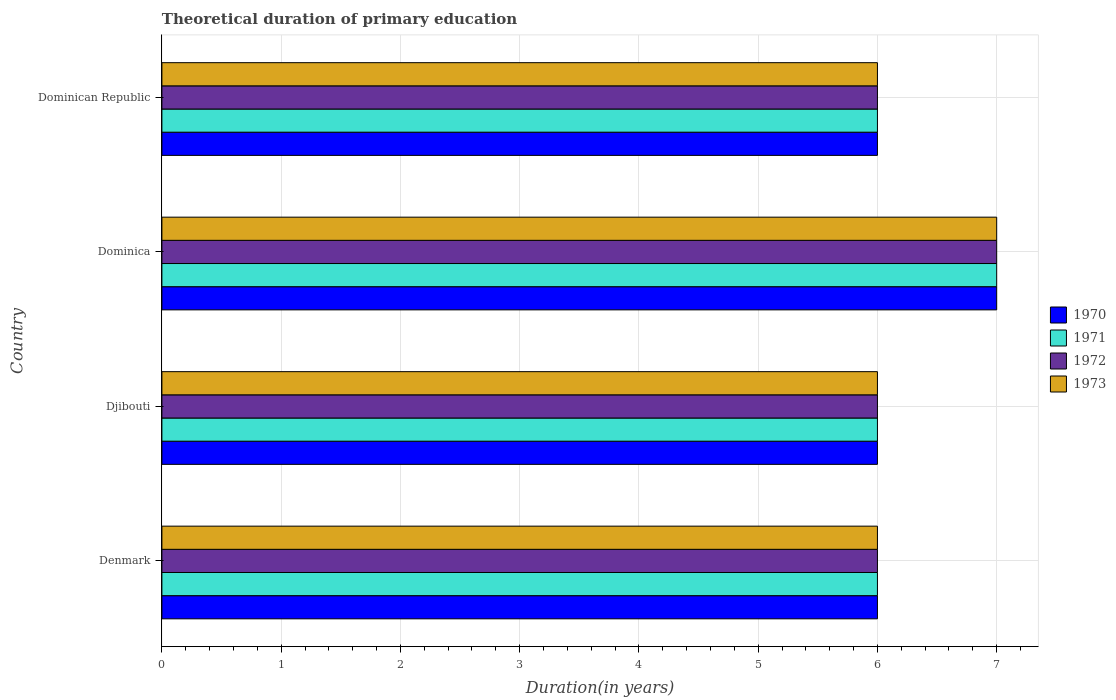How many different coloured bars are there?
Your answer should be very brief. 4. How many groups of bars are there?
Provide a succinct answer. 4. Are the number of bars on each tick of the Y-axis equal?
Provide a short and direct response. Yes. How many bars are there on the 3rd tick from the top?
Your answer should be very brief. 4. What is the label of the 2nd group of bars from the top?
Offer a very short reply. Dominica. Across all countries, what is the maximum total theoretical duration of primary education in 1972?
Offer a very short reply. 7. Across all countries, what is the minimum total theoretical duration of primary education in 1971?
Ensure brevity in your answer.  6. In which country was the total theoretical duration of primary education in 1971 maximum?
Offer a terse response. Dominica. What is the difference between the total theoretical duration of primary education in 1971 in Djibouti and that in Dominica?
Offer a terse response. -1. What is the difference between the total theoretical duration of primary education in 1970 in Denmark and the total theoretical duration of primary education in 1972 in Djibouti?
Provide a succinct answer. 0. What is the average total theoretical duration of primary education in 1972 per country?
Give a very brief answer. 6.25. What is the ratio of the total theoretical duration of primary education in 1971 in Dominica to that in Dominican Republic?
Ensure brevity in your answer.  1.17. Is the difference between the total theoretical duration of primary education in 1971 in Denmark and Dominica greater than the difference between the total theoretical duration of primary education in 1972 in Denmark and Dominica?
Offer a very short reply. No. In how many countries, is the total theoretical duration of primary education in 1971 greater than the average total theoretical duration of primary education in 1971 taken over all countries?
Offer a terse response. 1. What does the 4th bar from the top in Denmark represents?
Make the answer very short. 1970. Is it the case that in every country, the sum of the total theoretical duration of primary education in 1971 and total theoretical duration of primary education in 1972 is greater than the total theoretical duration of primary education in 1970?
Your answer should be very brief. Yes. Are all the bars in the graph horizontal?
Make the answer very short. Yes. How many countries are there in the graph?
Offer a terse response. 4. What is the difference between two consecutive major ticks on the X-axis?
Provide a short and direct response. 1. Does the graph contain any zero values?
Provide a short and direct response. No. Does the graph contain grids?
Your response must be concise. Yes. Where does the legend appear in the graph?
Provide a short and direct response. Center right. How many legend labels are there?
Offer a terse response. 4. How are the legend labels stacked?
Offer a very short reply. Vertical. What is the title of the graph?
Your answer should be compact. Theoretical duration of primary education. Does "2001" appear as one of the legend labels in the graph?
Provide a succinct answer. No. What is the label or title of the X-axis?
Your answer should be very brief. Duration(in years). What is the Duration(in years) of 1970 in Denmark?
Provide a succinct answer. 6. What is the Duration(in years) of 1971 in Denmark?
Provide a short and direct response. 6. What is the Duration(in years) of 1972 in Denmark?
Offer a terse response. 6. What is the Duration(in years) in 1973 in Denmark?
Your answer should be very brief. 6. What is the Duration(in years) of 1970 in Djibouti?
Offer a very short reply. 6. What is the Duration(in years) of 1972 in Djibouti?
Provide a short and direct response. 6. What is the Duration(in years) of 1972 in Dominica?
Ensure brevity in your answer.  7. What is the Duration(in years) in 1972 in Dominican Republic?
Offer a terse response. 6. Across all countries, what is the maximum Duration(in years) of 1972?
Make the answer very short. 7. Across all countries, what is the maximum Duration(in years) of 1973?
Keep it short and to the point. 7. Across all countries, what is the minimum Duration(in years) of 1972?
Your answer should be compact. 6. What is the total Duration(in years) in 1973 in the graph?
Your response must be concise. 25. What is the difference between the Duration(in years) in 1972 in Denmark and that in Djibouti?
Your answer should be very brief. 0. What is the difference between the Duration(in years) in 1971 in Denmark and that in Dominica?
Provide a short and direct response. -1. What is the difference between the Duration(in years) of 1970 in Denmark and that in Dominican Republic?
Ensure brevity in your answer.  0. What is the difference between the Duration(in years) of 1971 in Denmark and that in Dominican Republic?
Ensure brevity in your answer.  0. What is the difference between the Duration(in years) in 1972 in Denmark and that in Dominican Republic?
Keep it short and to the point. 0. What is the difference between the Duration(in years) in 1971 in Djibouti and that in Dominica?
Your answer should be compact. -1. What is the difference between the Duration(in years) in 1972 in Djibouti and that in Dominica?
Make the answer very short. -1. What is the difference between the Duration(in years) of 1970 in Djibouti and that in Dominican Republic?
Ensure brevity in your answer.  0. What is the difference between the Duration(in years) of 1971 in Dominica and that in Dominican Republic?
Keep it short and to the point. 1. What is the difference between the Duration(in years) in 1972 in Dominica and that in Dominican Republic?
Provide a short and direct response. 1. What is the difference between the Duration(in years) in 1973 in Dominica and that in Dominican Republic?
Provide a short and direct response. 1. What is the difference between the Duration(in years) of 1970 in Denmark and the Duration(in years) of 1971 in Djibouti?
Offer a very short reply. 0. What is the difference between the Duration(in years) in 1970 in Denmark and the Duration(in years) in 1972 in Djibouti?
Your answer should be compact. 0. What is the difference between the Duration(in years) of 1970 in Denmark and the Duration(in years) of 1973 in Djibouti?
Give a very brief answer. 0. What is the difference between the Duration(in years) of 1972 in Denmark and the Duration(in years) of 1973 in Djibouti?
Provide a succinct answer. 0. What is the difference between the Duration(in years) of 1970 in Denmark and the Duration(in years) of 1971 in Dominica?
Your answer should be compact. -1. What is the difference between the Duration(in years) in 1970 in Denmark and the Duration(in years) in 1973 in Dominica?
Give a very brief answer. -1. What is the difference between the Duration(in years) in 1971 in Denmark and the Duration(in years) in 1972 in Dominica?
Offer a very short reply. -1. What is the difference between the Duration(in years) in 1971 in Denmark and the Duration(in years) in 1973 in Dominica?
Make the answer very short. -1. What is the difference between the Duration(in years) of 1972 in Denmark and the Duration(in years) of 1973 in Dominica?
Keep it short and to the point. -1. What is the difference between the Duration(in years) of 1970 in Denmark and the Duration(in years) of 1971 in Dominican Republic?
Offer a terse response. 0. What is the difference between the Duration(in years) of 1970 in Denmark and the Duration(in years) of 1972 in Dominican Republic?
Give a very brief answer. 0. What is the difference between the Duration(in years) in 1970 in Denmark and the Duration(in years) in 1973 in Dominican Republic?
Your answer should be very brief. 0. What is the difference between the Duration(in years) in 1971 in Denmark and the Duration(in years) in 1972 in Dominican Republic?
Give a very brief answer. 0. What is the difference between the Duration(in years) in 1970 in Djibouti and the Duration(in years) in 1971 in Dominica?
Ensure brevity in your answer.  -1. What is the difference between the Duration(in years) of 1971 in Djibouti and the Duration(in years) of 1973 in Dominica?
Your response must be concise. -1. What is the difference between the Duration(in years) in 1972 in Djibouti and the Duration(in years) in 1973 in Dominica?
Make the answer very short. -1. What is the difference between the Duration(in years) of 1970 in Djibouti and the Duration(in years) of 1971 in Dominican Republic?
Your response must be concise. 0. What is the difference between the Duration(in years) of 1970 in Djibouti and the Duration(in years) of 1973 in Dominican Republic?
Offer a terse response. 0. What is the difference between the Duration(in years) of 1972 in Djibouti and the Duration(in years) of 1973 in Dominican Republic?
Your response must be concise. 0. What is the difference between the Duration(in years) of 1970 in Dominica and the Duration(in years) of 1972 in Dominican Republic?
Provide a succinct answer. 1. What is the difference between the Duration(in years) in 1971 in Dominica and the Duration(in years) in 1972 in Dominican Republic?
Keep it short and to the point. 1. What is the difference between the Duration(in years) of 1971 in Dominica and the Duration(in years) of 1973 in Dominican Republic?
Give a very brief answer. 1. What is the difference between the Duration(in years) of 1972 in Dominica and the Duration(in years) of 1973 in Dominican Republic?
Offer a terse response. 1. What is the average Duration(in years) of 1970 per country?
Make the answer very short. 6.25. What is the average Duration(in years) of 1971 per country?
Provide a short and direct response. 6.25. What is the average Duration(in years) in 1972 per country?
Offer a very short reply. 6.25. What is the average Duration(in years) in 1973 per country?
Your answer should be very brief. 6.25. What is the difference between the Duration(in years) in 1970 and Duration(in years) in 1971 in Denmark?
Give a very brief answer. 0. What is the difference between the Duration(in years) of 1970 and Duration(in years) of 1973 in Denmark?
Give a very brief answer. 0. What is the difference between the Duration(in years) in 1972 and Duration(in years) in 1973 in Denmark?
Your answer should be very brief. 0. What is the difference between the Duration(in years) in 1970 and Duration(in years) in 1971 in Djibouti?
Provide a succinct answer. 0. What is the difference between the Duration(in years) of 1971 and Duration(in years) of 1973 in Djibouti?
Your answer should be compact. 0. What is the difference between the Duration(in years) of 1972 and Duration(in years) of 1973 in Djibouti?
Ensure brevity in your answer.  0. What is the difference between the Duration(in years) of 1970 and Duration(in years) of 1972 in Dominica?
Offer a terse response. 0. What is the difference between the Duration(in years) in 1970 and Duration(in years) in 1973 in Dominica?
Your response must be concise. 0. What is the difference between the Duration(in years) in 1972 and Duration(in years) in 1973 in Dominican Republic?
Your answer should be compact. 0. What is the ratio of the Duration(in years) of 1970 in Denmark to that in Dominica?
Provide a succinct answer. 0.86. What is the ratio of the Duration(in years) of 1973 in Denmark to that in Dominica?
Ensure brevity in your answer.  0.86. What is the ratio of the Duration(in years) in 1970 in Denmark to that in Dominican Republic?
Offer a terse response. 1. What is the ratio of the Duration(in years) in 1973 in Denmark to that in Dominican Republic?
Offer a very short reply. 1. What is the ratio of the Duration(in years) of 1972 in Djibouti to that in Dominica?
Provide a short and direct response. 0.86. What is the ratio of the Duration(in years) of 1973 in Djibouti to that in Dominica?
Give a very brief answer. 0.86. What is the ratio of the Duration(in years) of 1972 in Djibouti to that in Dominican Republic?
Offer a terse response. 1. What is the ratio of the Duration(in years) in 1973 in Djibouti to that in Dominican Republic?
Give a very brief answer. 1. What is the ratio of the Duration(in years) of 1970 in Dominica to that in Dominican Republic?
Your answer should be very brief. 1.17. What is the ratio of the Duration(in years) of 1973 in Dominica to that in Dominican Republic?
Keep it short and to the point. 1.17. What is the difference between the highest and the second highest Duration(in years) in 1971?
Your answer should be very brief. 1. What is the difference between the highest and the second highest Duration(in years) in 1972?
Provide a short and direct response. 1. What is the difference between the highest and the second highest Duration(in years) of 1973?
Provide a succinct answer. 1. 